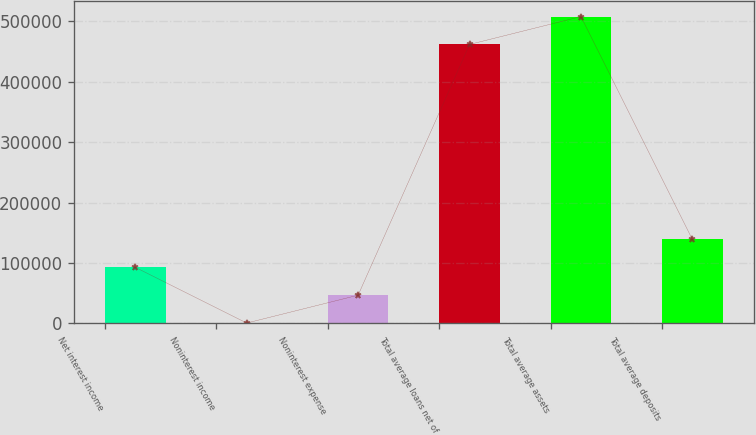<chart> <loc_0><loc_0><loc_500><loc_500><bar_chart><fcel>Net interest income<fcel>Noninterest income<fcel>Noninterest expense<fcel>Total average loans net of<fcel>Total average assets<fcel>Total average deposits<nl><fcel>92736.2<fcel>496<fcel>46616.1<fcel>461620<fcel>507740<fcel>138856<nl></chart> 